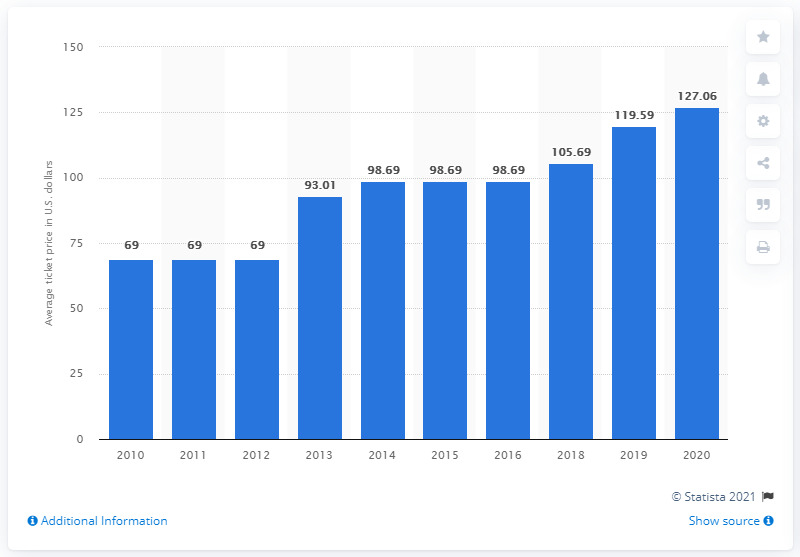Mention a couple of crucial points in this snapshot. The average ticket price for Philadelphia Eagles games in 2020 was $127.06. 